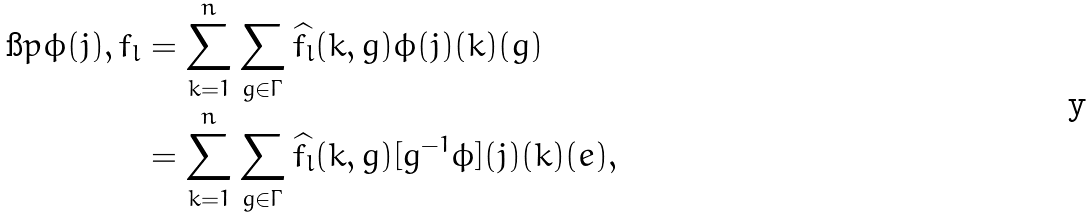<formula> <loc_0><loc_0><loc_500><loc_500>\i p { \phi ( j ) , f _ { l } } & = \sum _ { k = 1 } ^ { n } \sum _ { g \in \Gamma } \widehat { f _ { l } } ( k , g ) \phi ( j ) ( k ) ( g ) \\ & = \sum _ { k = 1 } ^ { n } \sum _ { g \in \Gamma } \widehat { f _ { l } } ( k , g ) [ g ^ { - 1 } \phi ] ( j ) ( k ) ( e ) ,</formula> 